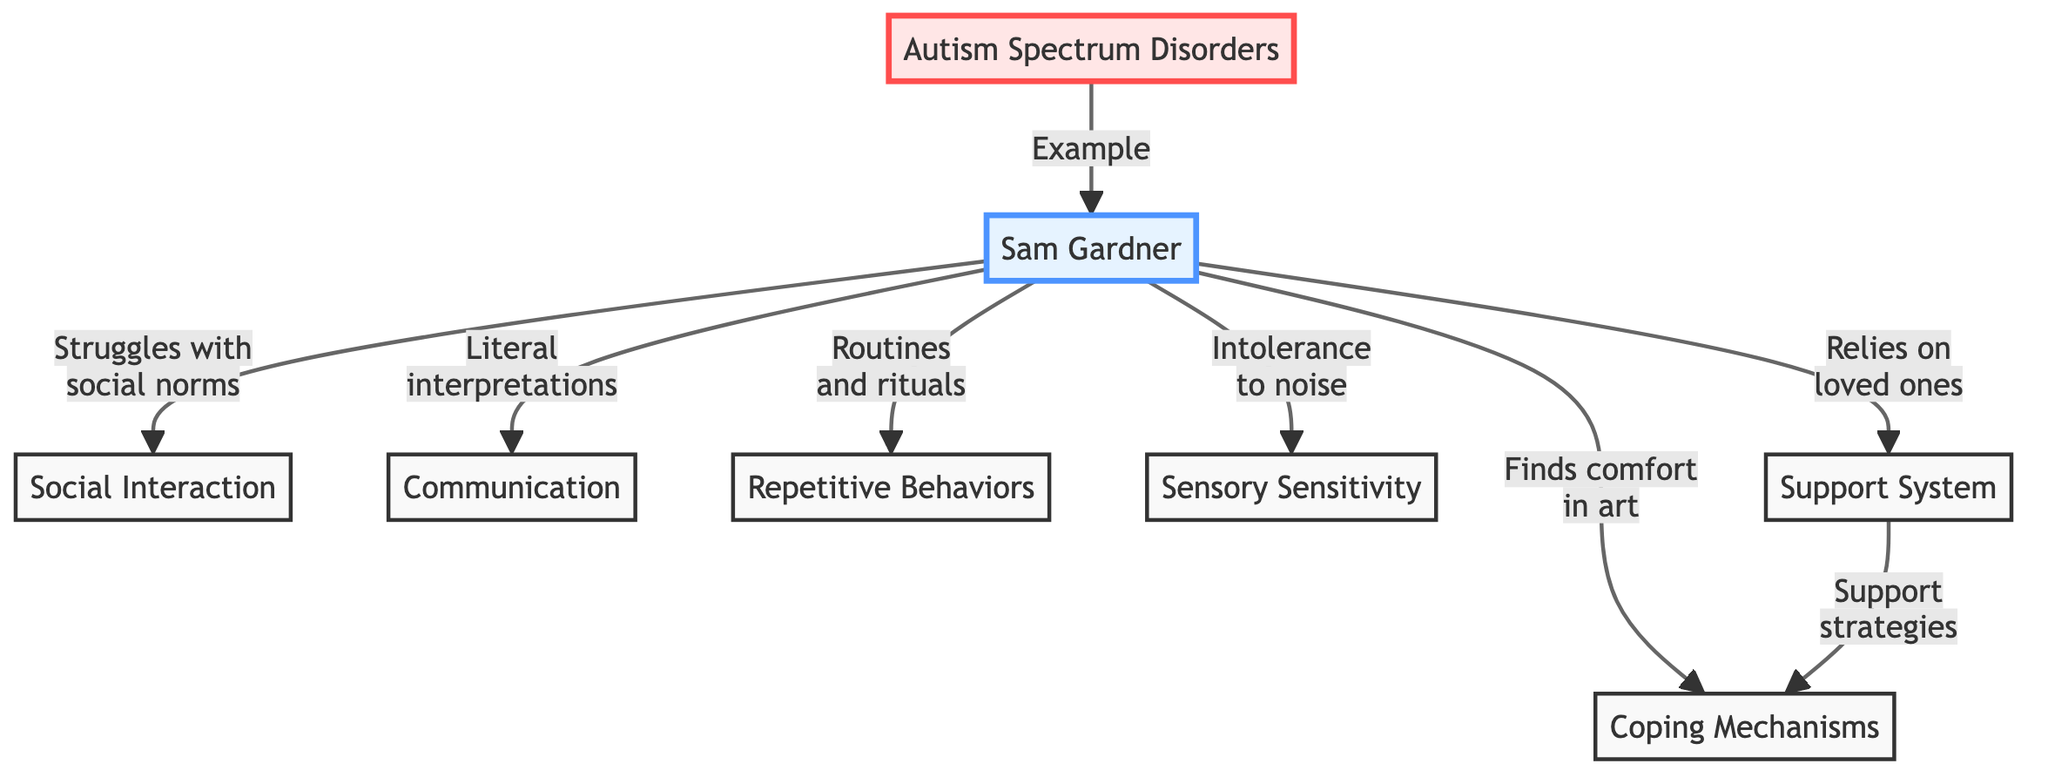What is the main subject of the diagram? The first node in the diagram, labeled "Autism Spectrum Disorders," indicates that the main subject is autism spectrum disorders, which serves as the foundation for the other elements presented.
Answer: Autism Spectrum Disorders Which character is primarily associated with the experiences depicted? The second node in the diagram is labeled "Sam Gardner," indicating that he is the character primarily associated with the experiences and challenges being explored in relation to autism.
Answer: Sam Gardner How many key aspects of Sam's experiences are illustrated in the diagram? The diagram displays six key aspects branching out from Sam Gardner: Social Interaction, Communication, Repetitive Behaviors, Sensory Sensitivity, Support System, and Coping Mechanisms. Counting these elements provides the answer.
Answer: 6 What relationship exists between Sam Gardner and "Support System"? The diagram shows that Sam Gardner relies on a "Support System," which leads to the node "Coping Mechanisms." This indicates that support is a foundational aspect of Sam's coping strategies.
Answer: Coping Mechanisms Which behavior does Sam Gardner struggle with in social contexts? One branch connects Sam Gardner to the aspect labeled "Struggles with social norms," indicating that this is a specific challenge he faces in social interactions.
Answer: Struggles with social norms What is one of Sam’s coping mechanisms? The diagram connects Sam Gardner to the node "Finds comfort in art," which suggests that this is one of the coping mechanisms he uses to deal with his experiences related to autism.
Answer: Finds comfort in art What type of sensitivity does Sam Gardner show according to the diagram? The aspect labeled "Intolerance to noise" indicates that he exhibits sensory sensitivity, particularly concerning auditory stimuli.
Answer: Intolerance to noise How does the support system relate to coping mechanisms? The diagram indicates a directional relationship where "Support System" leads to "Support strategies," which then connects to "Coping Mechanisms," suggesting that having a support system is vital for developing coping strategies.
Answer: Support strategies In what ways does Sam Gardner's communication style manifest according to the diagram? The diagram specifies that he has "Literal interpretations" as a characteristic of his communication style, highlighting a particular way he perceives verbal exchanges.
Answer: Literal interpretations 